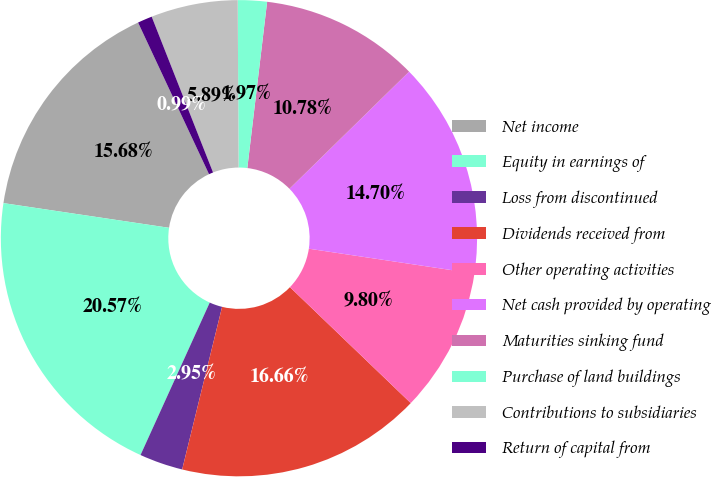Convert chart to OTSL. <chart><loc_0><loc_0><loc_500><loc_500><pie_chart><fcel>Net income<fcel>Equity in earnings of<fcel>Loss from discontinued<fcel>Dividends received from<fcel>Other operating activities<fcel>Net cash provided by operating<fcel>Maturities sinking fund<fcel>Purchase of land buildings<fcel>Contributions to subsidiaries<fcel>Return of capital from<nl><fcel>15.68%<fcel>20.57%<fcel>2.95%<fcel>16.66%<fcel>9.8%<fcel>14.7%<fcel>10.78%<fcel>1.97%<fcel>5.89%<fcel>0.99%<nl></chart> 